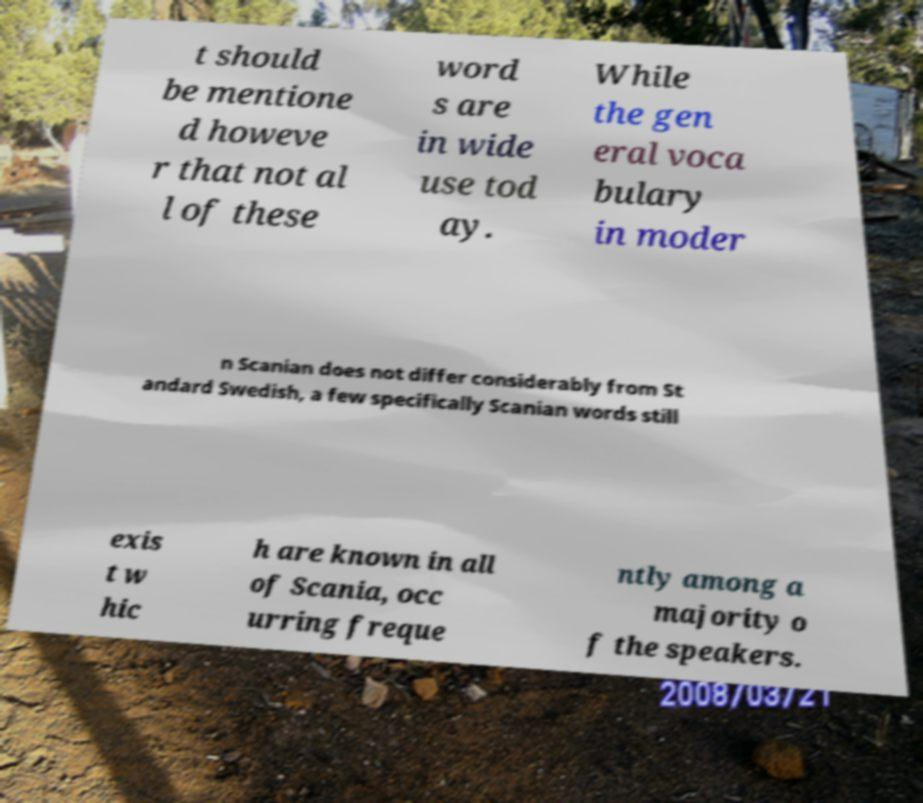For documentation purposes, I need the text within this image transcribed. Could you provide that? t should be mentione d howeve r that not al l of these word s are in wide use tod ay. While the gen eral voca bulary in moder n Scanian does not differ considerably from St andard Swedish, a few specifically Scanian words still exis t w hic h are known in all of Scania, occ urring freque ntly among a majority o f the speakers. 